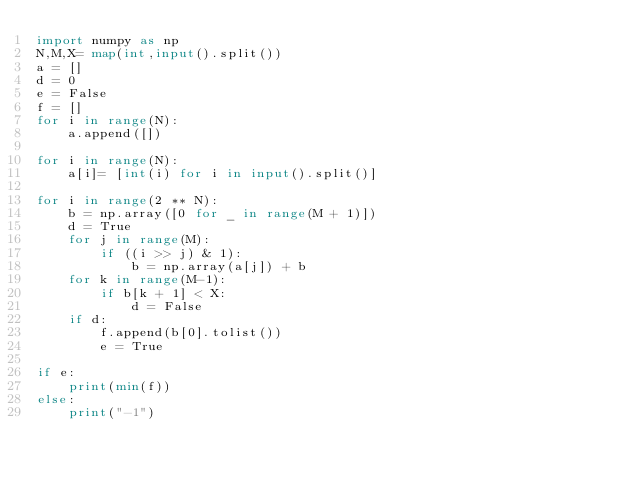<code> <loc_0><loc_0><loc_500><loc_500><_Python_>import numpy as np
N,M,X= map(int,input().split())
a = []
d = 0
e = False
f = []
for i in range(N):
    a.append([])

for i in range(N):
    a[i]= [int(i) for i in input().split()]

for i in range(2 ** N):
    b = np.array([0 for _ in range(M + 1)])
    d = True
    for j in range(M):
        if ((i >> j) & 1):
            b = np.array(a[j]) + b
    for k in range(M-1):
        if b[k + 1] < X:
            d = False
    if d:
        f.append(b[0].tolist())
        e = True

if e:
    print(min(f))
else:
    print("-1")</code> 